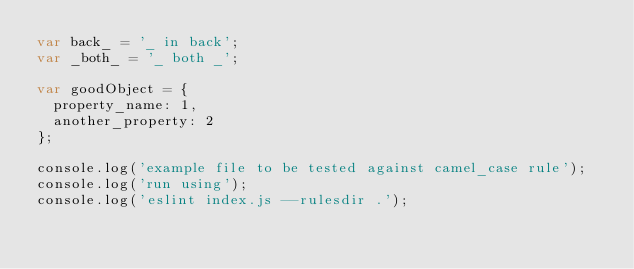Convert code to text. <code><loc_0><loc_0><loc_500><loc_500><_JavaScript_>var back_ = '_ in back';
var _both_ = '_ both _';

var goodObject = {
  property_name: 1,
  another_property: 2
};

console.log('example file to be tested against camel_case rule');
console.log('run using');
console.log('eslint index.js --rulesdir .');
</code> 